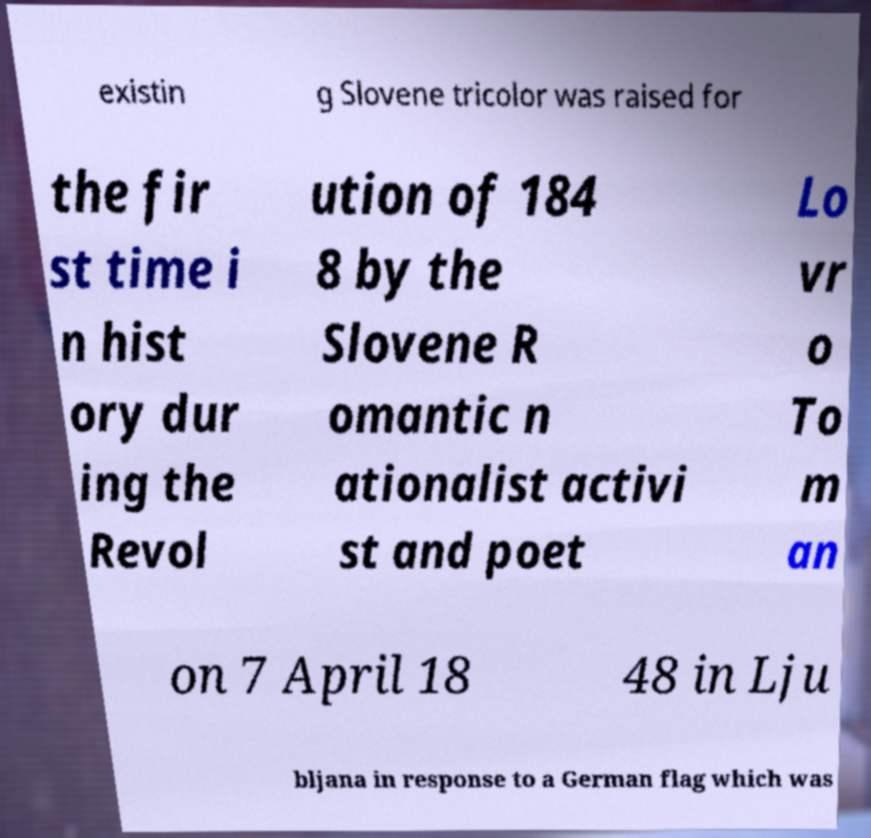There's text embedded in this image that I need extracted. Can you transcribe it verbatim? existin g Slovene tricolor was raised for the fir st time i n hist ory dur ing the Revol ution of 184 8 by the Slovene R omantic n ationalist activi st and poet Lo vr o To m an on 7 April 18 48 in Lju bljana in response to a German flag which was 